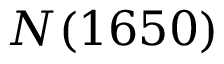<formula> <loc_0><loc_0><loc_500><loc_500>N ( 1 6 5 0 )</formula> 